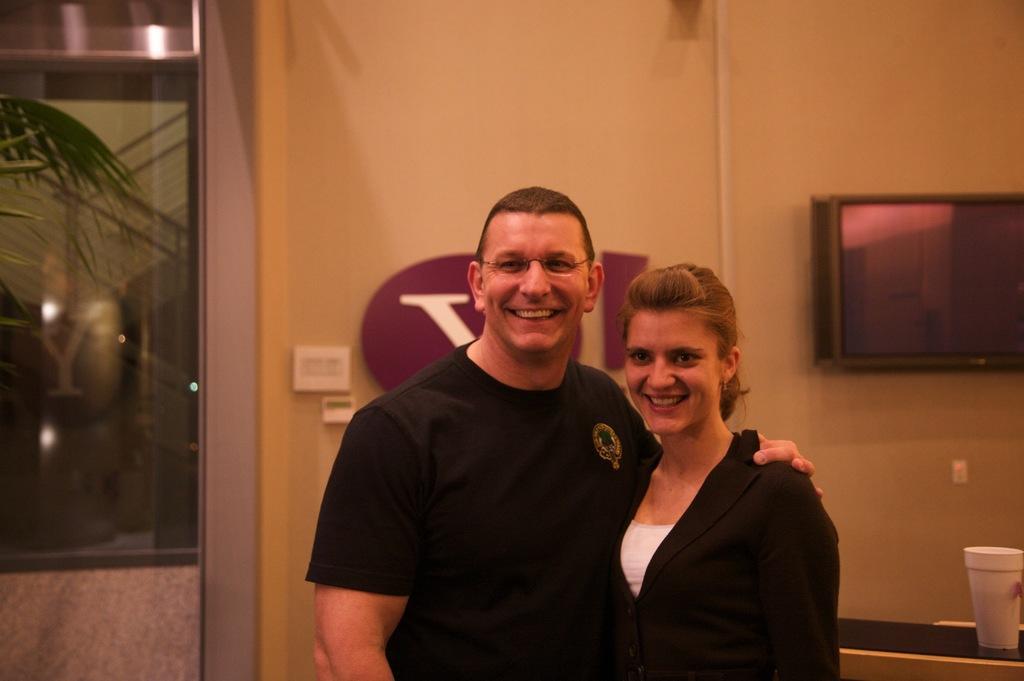How would you summarize this image in a sentence or two? In this image we can see a man and a woman standing. On the right bottom we can see a glass on the table. On the backside we can see some leaves of a plant, a door, switch board and a television on a wall. 